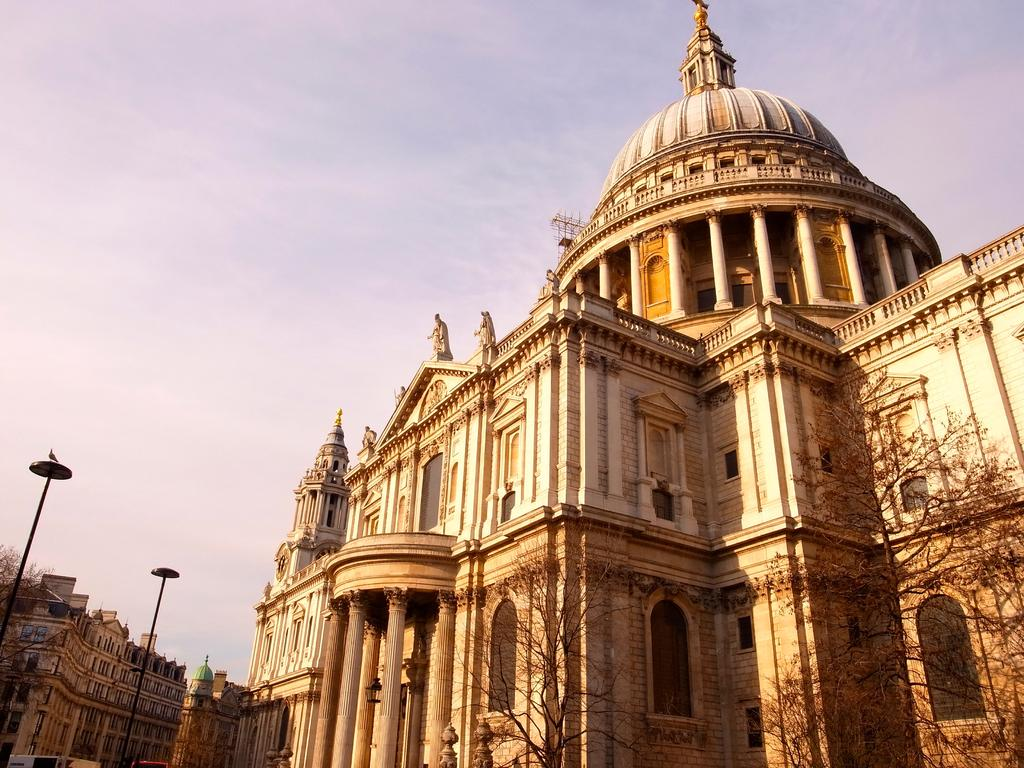What type of structures can be seen in the image? There are buildings in the image. Can you describe the vegetation in the image? There are dried trees in the right corner of the image. What type of teaching is taking place in the image? There is no teaching activity present in the image. How many planes can be seen in the image? There are no planes visible in the image. 